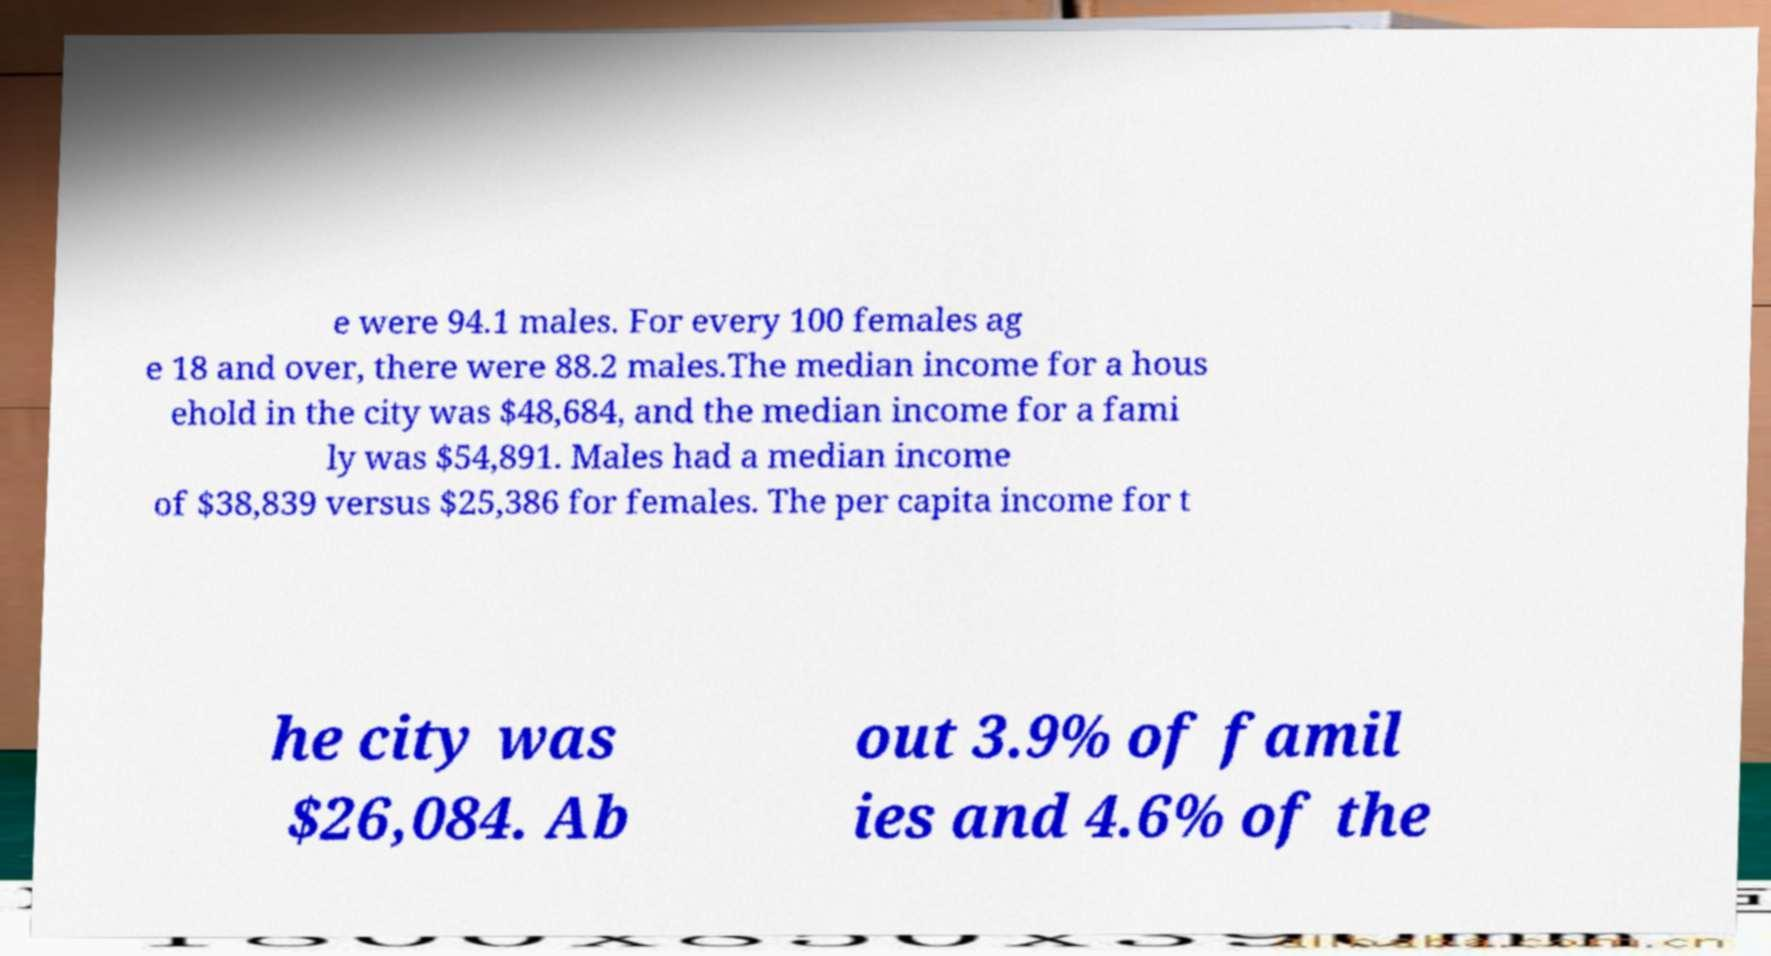For documentation purposes, I need the text within this image transcribed. Could you provide that? e were 94.1 males. For every 100 females ag e 18 and over, there were 88.2 males.The median income for a hous ehold in the city was $48,684, and the median income for a fami ly was $54,891. Males had a median income of $38,839 versus $25,386 for females. The per capita income for t he city was $26,084. Ab out 3.9% of famil ies and 4.6% of the 